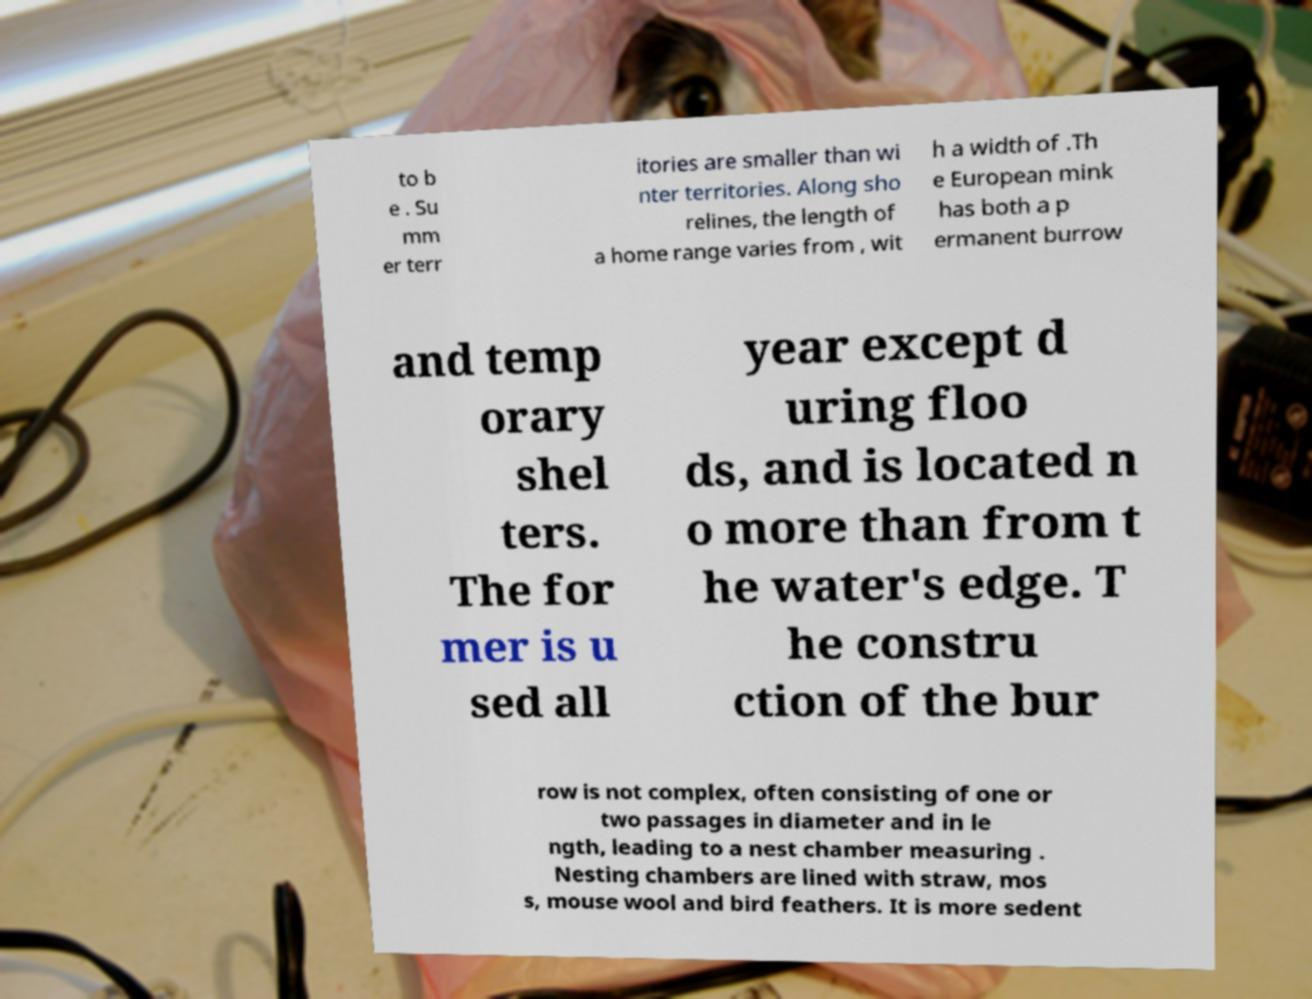For documentation purposes, I need the text within this image transcribed. Could you provide that? to b e . Su mm er terr itories are smaller than wi nter territories. Along sho relines, the length of a home range varies from , wit h a width of .Th e European mink has both a p ermanent burrow and temp orary shel ters. The for mer is u sed all year except d uring floo ds, and is located n o more than from t he water's edge. T he constru ction of the bur row is not complex, often consisting of one or two passages in diameter and in le ngth, leading to a nest chamber measuring . Nesting chambers are lined with straw, mos s, mouse wool and bird feathers. It is more sedent 